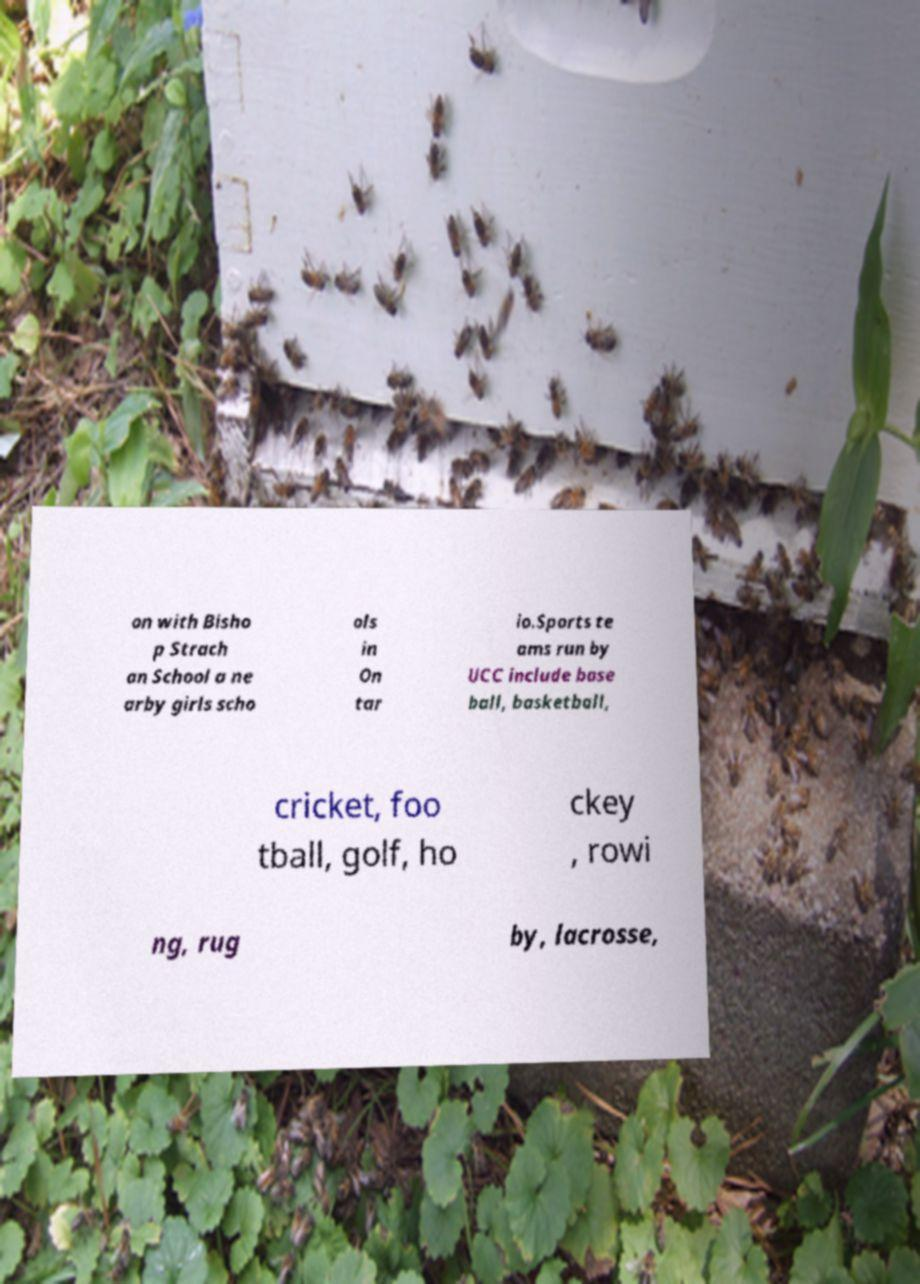Please read and relay the text visible in this image. What does it say? on with Bisho p Strach an School a ne arby girls scho ols in On tar io.Sports te ams run by UCC include base ball, basketball, cricket, foo tball, golf, ho ckey , rowi ng, rug by, lacrosse, 